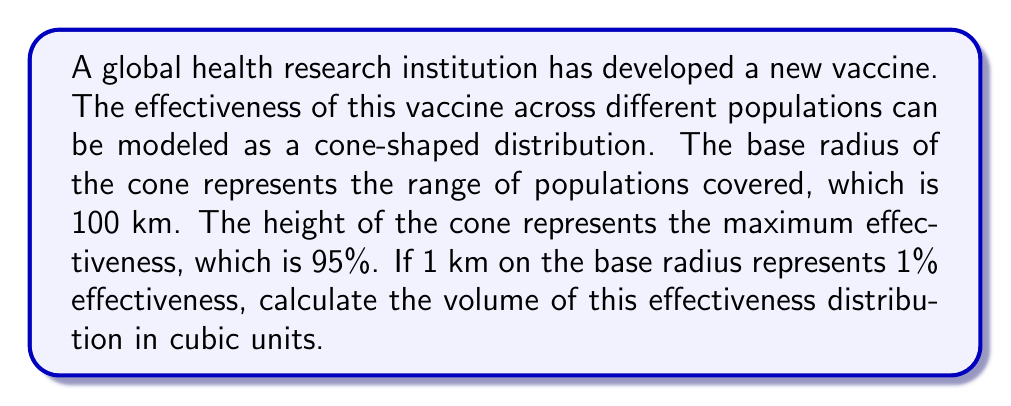Help me with this question. To solve this problem, we'll follow these steps:

1) First, recall the formula for the volume of a cone:
   $$V = \frac{1}{3}\pi r^2 h$$
   where $r$ is the radius of the base and $h$ is the height of the cone.

2) We're given:
   - Base radius (r) = 100 km
   - Height (h) = 95% = 95 km (since 1 km represents 1%)

3) Let's substitute these values into our formula:
   $$V = \frac{1}{3}\pi (100)^2 (95)$$

4) Simplify:
   $$V = \frac{1}{3}\pi (10000) (95)$$
   $$V = \frac{950000}{3}\pi$$

5) Calculate:
   $$V \approx 995379.57$$

6) Round to the nearest whole number:
   $$V \approx 995380$$

The units are cubic km, which in this context represents a combination of population coverage (km^2) and effectiveness (km).

[asy]
import graph3;
size(200);
currentprojection=perspective(6,3,2);
triple f(pair t) {return (t.x*cos(t.y),t.x*sin(t.y),0);}
revolution r=revolution(f,(0,0),(100,0),0,2pi);
draw(surface(r),paleblue+opacity(.5));
draw(r,blue);
triple A=(0,0,95);
draw(A--(100,0,0),dashed);
draw(A--(100*cos(pi/6),100*sin(pi/6),0),dashed);
draw(A--(100*cos(pi/3),100*sin(pi/3),0),dashed);
label("95%",A,N);
label("100 km",(-50,50,0),E);
[/asy]
Answer: 995380 cubic km 